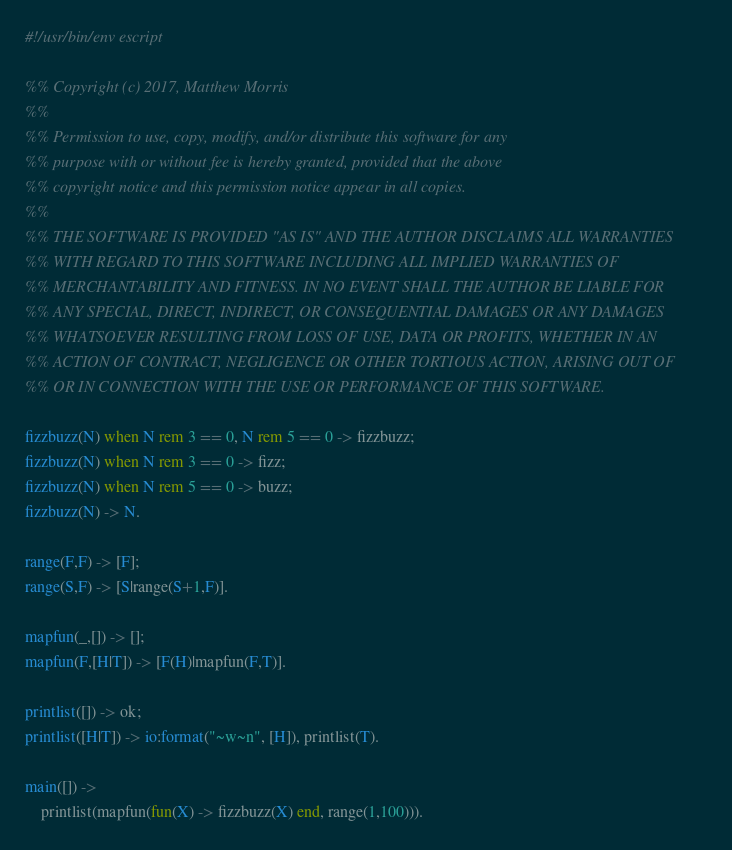Convert code to text. <code><loc_0><loc_0><loc_500><loc_500><_Erlang_>#!/usr/bin/env escript

%% Copyright (c) 2017, Matthew Morris
%%
%% Permission to use, copy, modify, and/or distribute this software for any
%% purpose with or without fee is hereby granted, provided that the above
%% copyright notice and this permission notice appear in all copies.
%%
%% THE SOFTWARE IS PROVIDED "AS IS" AND THE AUTHOR DISCLAIMS ALL WARRANTIES
%% WITH REGARD TO THIS SOFTWARE INCLUDING ALL IMPLIED WARRANTIES OF
%% MERCHANTABILITY AND FITNESS. IN NO EVENT SHALL THE AUTHOR BE LIABLE FOR
%% ANY SPECIAL, DIRECT, INDIRECT, OR CONSEQUENTIAL DAMAGES OR ANY DAMAGES
%% WHATSOEVER RESULTING FROM LOSS OF USE, DATA OR PROFITS, WHETHER IN AN
%% ACTION OF CONTRACT, NEGLIGENCE OR OTHER TORTIOUS ACTION, ARISING OUT OF
%% OR IN CONNECTION WITH THE USE OR PERFORMANCE OF THIS SOFTWARE.

fizzbuzz(N) when N rem 3 == 0, N rem 5 == 0 -> fizzbuzz;
fizzbuzz(N) when N rem 3 == 0 -> fizz;
fizzbuzz(N) when N rem 5 == 0 -> buzz;
fizzbuzz(N) -> N.

range(F,F) -> [F];
range(S,F) -> [S|range(S+1,F)].

mapfun(_,[]) -> [];
mapfun(F,[H|T]) -> [F(H)|mapfun(F,T)].

printlist([]) -> ok;
printlist([H|T]) -> io:format("~w~n", [H]), printlist(T).

main([]) ->
    printlist(mapfun(fun(X) -> fizzbuzz(X) end, range(1,100))).
</code> 